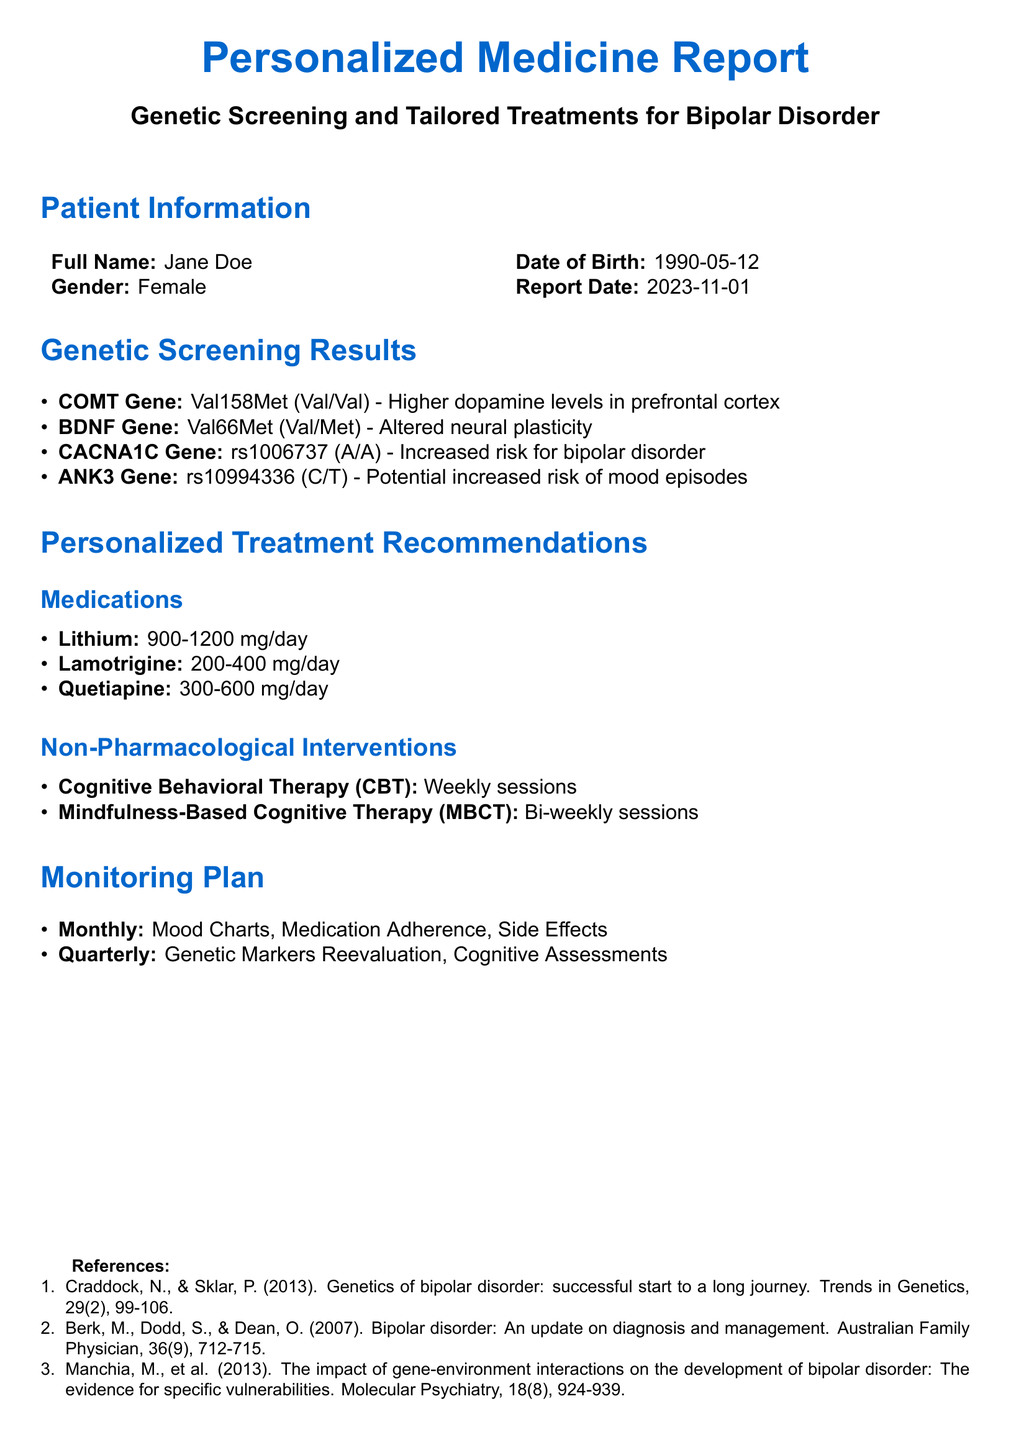What is the patient's full name? The patient's full name is listed at the beginning of the report under patient information.
Answer: Jane Doe What is the date of birth of the patient? The date of birth is mentioned alongside the patient's full name in the patient information section.
Answer: 1990-05-12 What is the report date? The report date is provided in the patient information section, indicating when the report was created.
Answer: 2023-11-01 Which gene indicates an increased risk for bipolar disorder? The genetic screening results identify the gene associated with increased risk for bipolar disorder.
Answer: CACNA1C Gene What is the recommended daily dosage for Lithium? The personalized treatment recommendations provide specific dosages for medications, including Lithium.
Answer: 900-1200 mg/day How often should cognitive behavioral therapy (CBT) sessions occur? The non-pharmacological interventions section specifies the frequency of CBT sessions.
Answer: Weekly sessions What is included in the monitoring plan on a monthly basis? The monitoring plan outlines the elements to be assessed monthly for the patient's treatment.
Answer: Mood Charts, Medication Adherence, Side Effects What is the purpose of genetic markers reevaluation? The monitoring plan indicates that genetic markers reevaluation is part of the quarterly assessments, suggesting ongoing assessment of risk.
Answer: Quarterly assessment Who are the authors of the reference list? The references section cites specific studies, and the first authors should be identified from those references for credit.
Answer: Craddock, N. & Sklar, P 